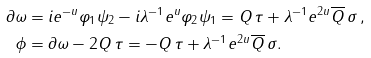<formula> <loc_0><loc_0><loc_500><loc_500>\partial \omega & = i e ^ { - u } \varphi _ { 1 } \psi _ { 2 } - i \lambda ^ { - 1 } e ^ { u } \varphi _ { 2 } \psi _ { 1 } = Q \, \tau + \lambda ^ { - 1 } e ^ { 2 u } \overline { Q } \, \sigma \, , \\ \phi & = \partial \omega - 2 Q \, \tau = - Q \, \tau + \lambda ^ { - 1 } e ^ { 2 u } \overline { Q } \, \sigma .</formula> 